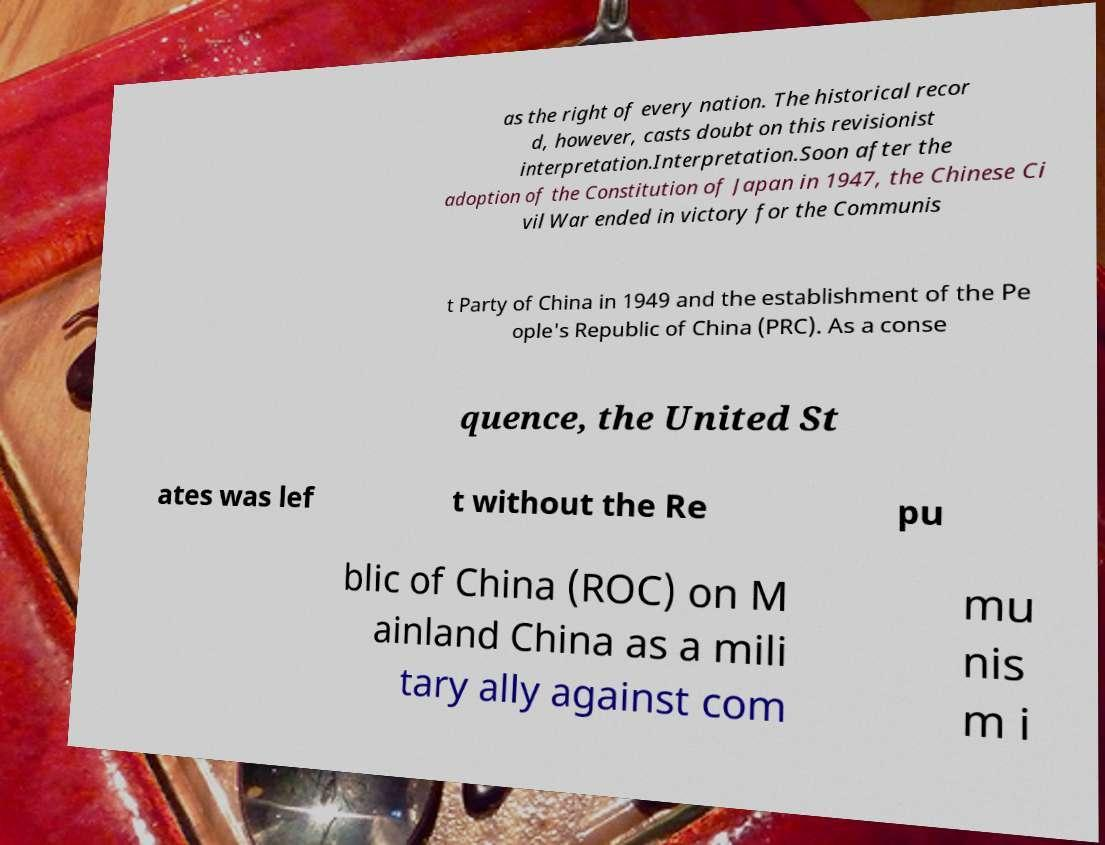Please identify and transcribe the text found in this image. as the right of every nation. The historical recor d, however, casts doubt on this revisionist interpretation.Interpretation.Soon after the adoption of the Constitution of Japan in 1947, the Chinese Ci vil War ended in victory for the Communis t Party of China in 1949 and the establishment of the Pe ople's Republic of China (PRC). As a conse quence, the United St ates was lef t without the Re pu blic of China (ROC) on M ainland China as a mili tary ally against com mu nis m i 